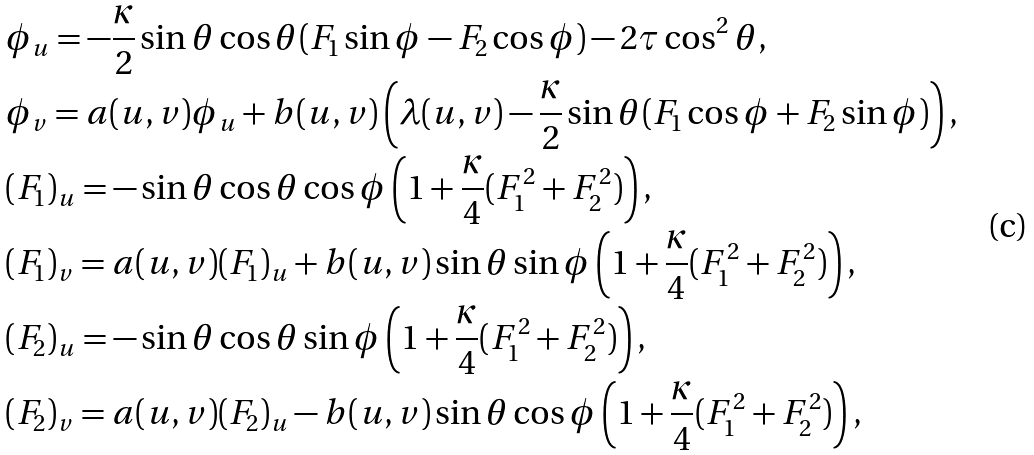Convert formula to latex. <formula><loc_0><loc_0><loc_500><loc_500>& \phi _ { u } = - \frac { \kappa } { 2 } \sin \theta \cos \theta ( F _ { 1 } \sin \phi - F _ { 2 } \cos \phi ) - 2 \tau \cos ^ { 2 } \theta , \\ & \phi _ { v } = a ( u , v ) \phi _ { u } + b ( u , v ) \left ( \lambda ( u , v ) - \frac { \kappa } { 2 } \sin \theta ( F _ { 1 } \cos \phi + F _ { 2 } \sin \phi ) \right ) , \\ & ( F _ { 1 } ) _ { u } = - \sin \theta \cos \theta \cos \phi \left ( 1 + \frac { \kappa } { 4 } ( F _ { 1 } ^ { 2 } + F _ { 2 } ^ { 2 } ) \right ) , \\ & ( F _ { 1 } ) _ { v } = a ( u , v ) ( F _ { 1 } ) _ { u } + b ( u , v ) \sin \theta \sin \phi \left ( 1 + \frac { \kappa } { 4 } ( F _ { 1 } ^ { 2 } + F _ { 2 } ^ { 2 } ) \right ) , \\ & ( F _ { 2 } ) _ { u } = - \sin \theta \cos \theta \sin \phi \left ( 1 + \frac { \kappa } { 4 } ( F _ { 1 } ^ { 2 } + F _ { 2 } ^ { 2 } ) \right ) , \\ & ( F _ { 2 } ) _ { v } = a ( u , v ) ( F _ { 2 } ) _ { u } - b ( u , v ) \sin \theta \cos \phi \left ( 1 + \frac { \kappa } { 4 } ( F _ { 1 } ^ { 2 } + F _ { 2 } ^ { 2 } ) \right ) ,</formula> 